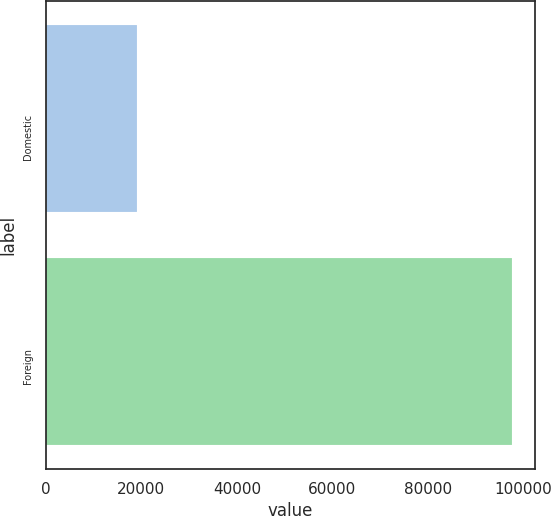Convert chart. <chart><loc_0><loc_0><loc_500><loc_500><bar_chart><fcel>Domestic<fcel>Foreign<nl><fcel>19051<fcel>97600<nl></chart> 